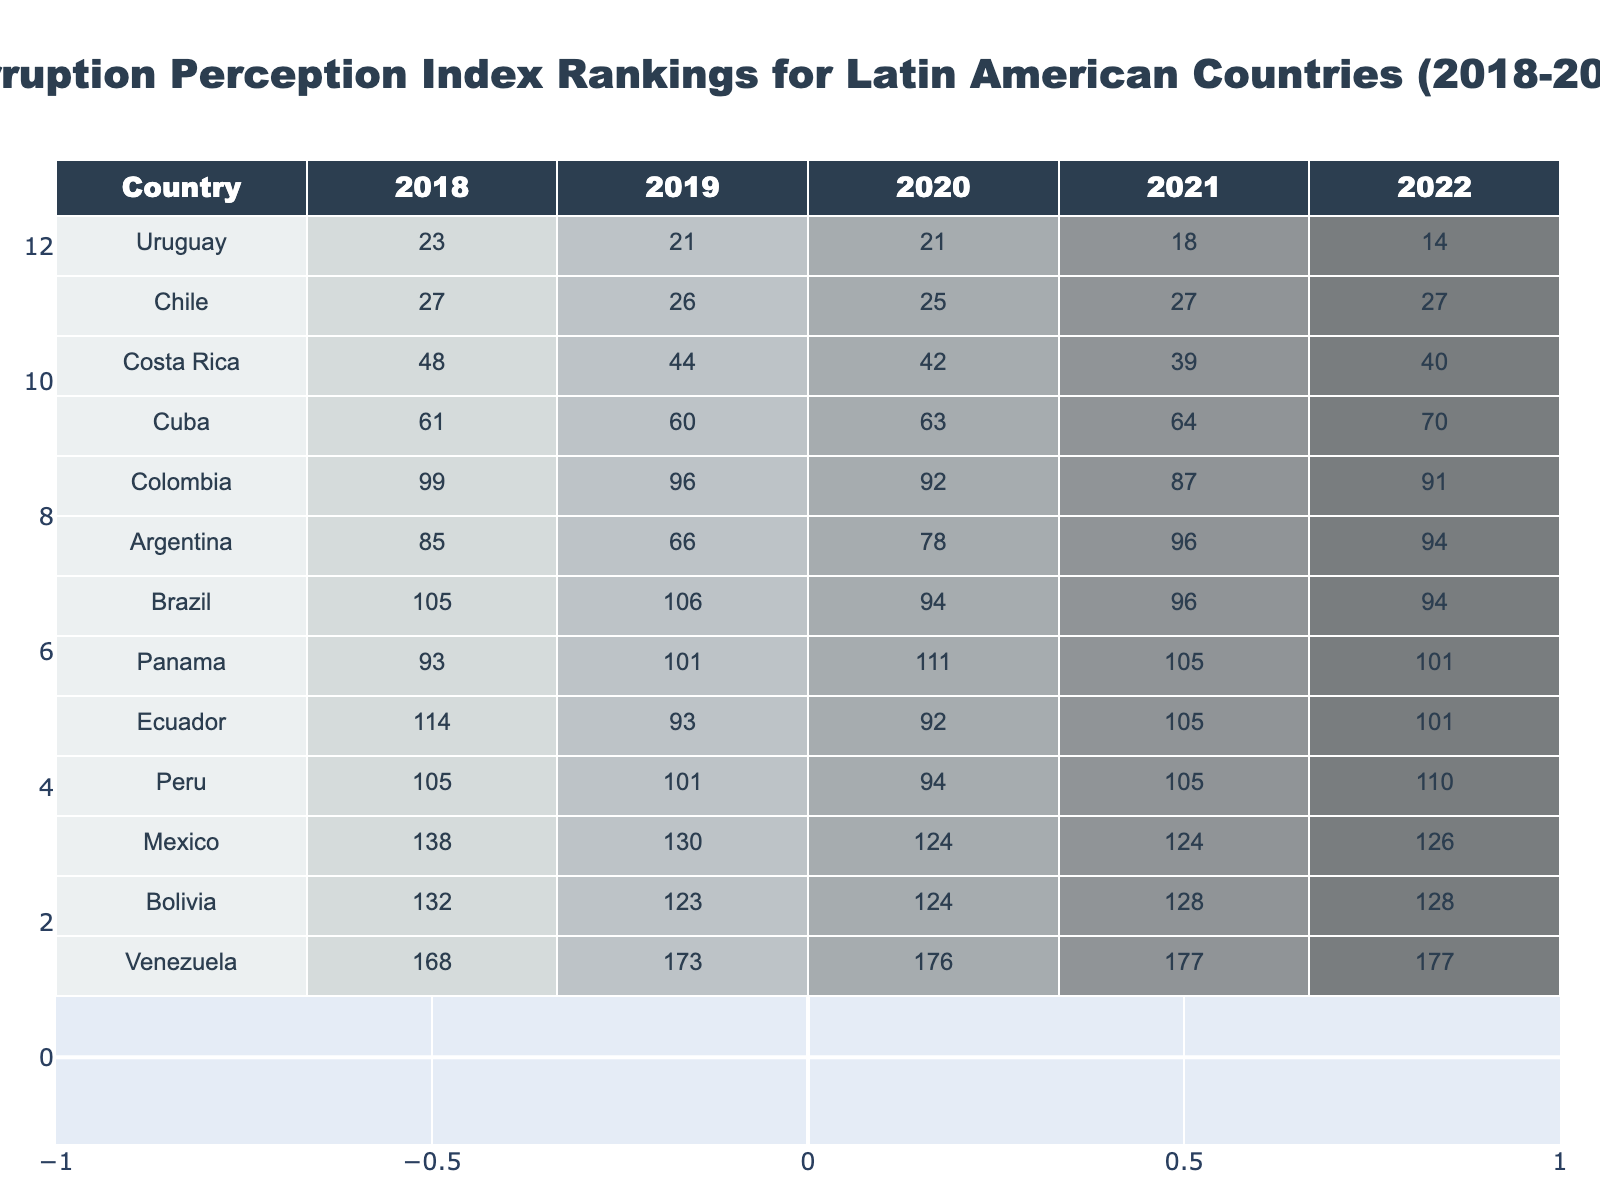What is the Corruption Perception Index ranking for Peru in 2021? In the table, the value listed for Peru under the 2021 column is 105.
Answer: 105 Which country had the highest Corruption Perception Index ranking in 2022? By examining the last column, Argentina has the highest ranking at 94 in 2022.
Answer: Argentina Did Cuba's ranking improve from 2018 to 2022? In 2018, Cuba's ranking was 61, and in 2022, it was 70, indicating a decline in its ranking over those years.
Answer: No What is the average ranking of Bolivia from 2018 to 2022? The rankings are 132, 123, 124, 128, and 128. Adding them gives 635, and dividing by 5 provides an average of 127.
Answer: 127 Which country consistently improved its ranking from 2018 to 2022? By reviewing the rankings for each country over the years, it appears that Chile remained stable at rankings 27 over the years after 2019.
Answer: No What is the difference in ranking for Colombia between 2018 and 2022? In 2018, Colombia was ranked 99, and in 2022 it was ranked 91. The difference is 99 - 91 = 8.
Answer: 8 Is there any country that had a ranking of over 100 in all five years? Checking the rankings, Panama, Peru, and Mexico all maintained a rank of over 100 across all years presented.
Answer: Yes What is the trend of Argentina's ranking throughout the years 2018 to 2022? Argentina's ranking began at 85 in 2018, decreased to 66 in 2019, then increased to 96 in 2021 and slightly decreased to 94 in 2022. This indicates fluctuating but generally negative improvements.
Answer: Fluctuating Which country had the lowest ranking in 2020? By looking at the 2020 column, Venezuela ranks lowest at 176.
Answer: Venezuela What can be said about the general trend of the top-ranked countries (1-5 ranks) from 2018 to 2022? By reviewing the top-ranked countries, they exhibit a general trend of stability and slight improvement on average over the years, indicating being at relatively lower corruption levels.
Answer: Stable with slight improvement 